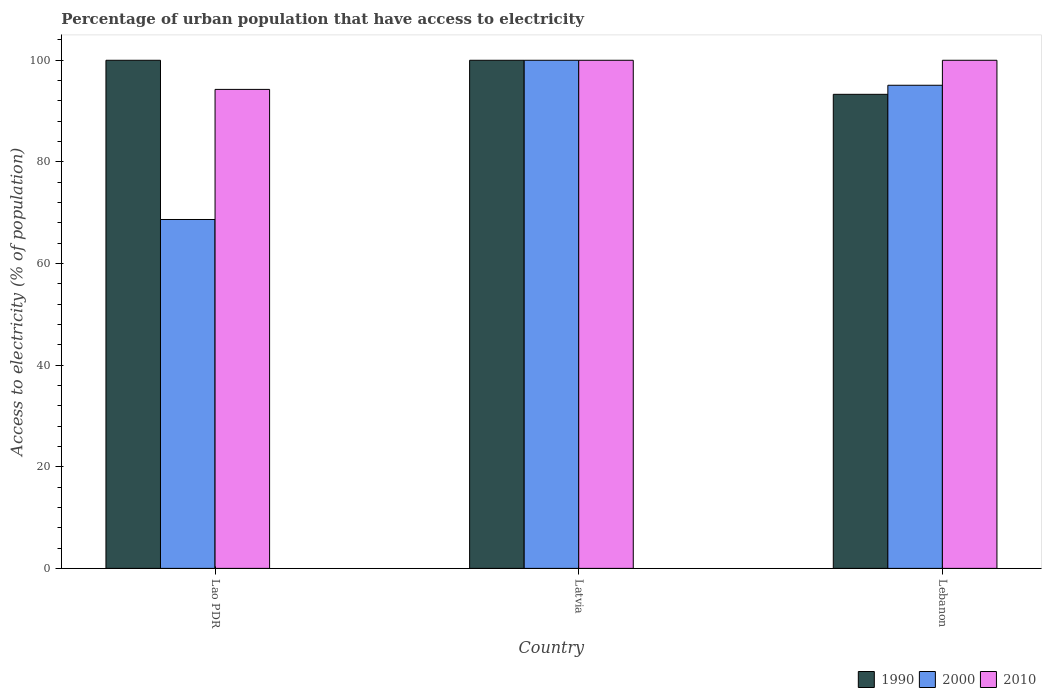How many different coloured bars are there?
Provide a short and direct response. 3. Are the number of bars per tick equal to the number of legend labels?
Offer a terse response. Yes. How many bars are there on the 3rd tick from the left?
Provide a short and direct response. 3. How many bars are there on the 1st tick from the right?
Give a very brief answer. 3. What is the label of the 1st group of bars from the left?
Offer a very short reply. Lao PDR. In how many cases, is the number of bars for a given country not equal to the number of legend labels?
Your answer should be very brief. 0. Across all countries, what is the maximum percentage of urban population that have access to electricity in 2010?
Provide a short and direct response. 100. Across all countries, what is the minimum percentage of urban population that have access to electricity in 2010?
Ensure brevity in your answer.  94.27. In which country was the percentage of urban population that have access to electricity in 1990 maximum?
Keep it short and to the point. Lao PDR. In which country was the percentage of urban population that have access to electricity in 1990 minimum?
Keep it short and to the point. Lebanon. What is the total percentage of urban population that have access to electricity in 1990 in the graph?
Give a very brief answer. 293.3. What is the difference between the percentage of urban population that have access to electricity in 2000 in Lao PDR and that in Lebanon?
Offer a terse response. -26.42. What is the difference between the percentage of urban population that have access to electricity in 1990 in Lebanon and the percentage of urban population that have access to electricity in 2010 in Latvia?
Keep it short and to the point. -6.7. What is the average percentage of urban population that have access to electricity in 2010 per country?
Offer a terse response. 98.09. What is the difference between the percentage of urban population that have access to electricity of/in 2010 and percentage of urban population that have access to electricity of/in 2000 in Lebanon?
Your answer should be very brief. 4.92. What is the ratio of the percentage of urban population that have access to electricity in 2000 in Lao PDR to that in Lebanon?
Offer a terse response. 0.72. Is the percentage of urban population that have access to electricity in 1990 in Lao PDR less than that in Lebanon?
Keep it short and to the point. No. Is the difference between the percentage of urban population that have access to electricity in 2010 in Latvia and Lebanon greater than the difference between the percentage of urban population that have access to electricity in 2000 in Latvia and Lebanon?
Provide a short and direct response. No. What is the difference between the highest and the second highest percentage of urban population that have access to electricity in 2010?
Make the answer very short. 5.73. What is the difference between the highest and the lowest percentage of urban population that have access to electricity in 1990?
Provide a succinct answer. 6.7. In how many countries, is the percentage of urban population that have access to electricity in 2000 greater than the average percentage of urban population that have access to electricity in 2000 taken over all countries?
Provide a succinct answer. 2. What does the 2nd bar from the right in Lebanon represents?
Your answer should be very brief. 2000. Is it the case that in every country, the sum of the percentage of urban population that have access to electricity in 2010 and percentage of urban population that have access to electricity in 2000 is greater than the percentage of urban population that have access to electricity in 1990?
Provide a succinct answer. Yes. Are all the bars in the graph horizontal?
Your response must be concise. No. How many countries are there in the graph?
Keep it short and to the point. 3. What is the difference between two consecutive major ticks on the Y-axis?
Offer a terse response. 20. Does the graph contain any zero values?
Your response must be concise. No. What is the title of the graph?
Provide a short and direct response. Percentage of urban population that have access to electricity. What is the label or title of the Y-axis?
Your answer should be very brief. Access to electricity (% of population). What is the Access to electricity (% of population) of 1990 in Lao PDR?
Your response must be concise. 100. What is the Access to electricity (% of population) in 2000 in Lao PDR?
Your answer should be compact. 68.67. What is the Access to electricity (% of population) in 2010 in Lao PDR?
Your response must be concise. 94.27. What is the Access to electricity (% of population) of 1990 in Latvia?
Provide a succinct answer. 100. What is the Access to electricity (% of population) of 1990 in Lebanon?
Your answer should be very brief. 93.3. What is the Access to electricity (% of population) in 2000 in Lebanon?
Ensure brevity in your answer.  95.08. What is the Access to electricity (% of population) in 2010 in Lebanon?
Ensure brevity in your answer.  100. Across all countries, what is the maximum Access to electricity (% of population) of 1990?
Your response must be concise. 100. Across all countries, what is the maximum Access to electricity (% of population) of 2000?
Your answer should be compact. 100. Across all countries, what is the maximum Access to electricity (% of population) of 2010?
Provide a succinct answer. 100. Across all countries, what is the minimum Access to electricity (% of population) of 1990?
Keep it short and to the point. 93.3. Across all countries, what is the minimum Access to electricity (% of population) of 2000?
Offer a terse response. 68.67. Across all countries, what is the minimum Access to electricity (% of population) of 2010?
Ensure brevity in your answer.  94.27. What is the total Access to electricity (% of population) of 1990 in the graph?
Your response must be concise. 293.3. What is the total Access to electricity (% of population) in 2000 in the graph?
Offer a very short reply. 263.75. What is the total Access to electricity (% of population) in 2010 in the graph?
Your response must be concise. 294.27. What is the difference between the Access to electricity (% of population) in 1990 in Lao PDR and that in Latvia?
Your answer should be very brief. 0. What is the difference between the Access to electricity (% of population) in 2000 in Lao PDR and that in Latvia?
Give a very brief answer. -31.33. What is the difference between the Access to electricity (% of population) of 2010 in Lao PDR and that in Latvia?
Offer a terse response. -5.73. What is the difference between the Access to electricity (% of population) in 1990 in Lao PDR and that in Lebanon?
Offer a terse response. 6.7. What is the difference between the Access to electricity (% of population) in 2000 in Lao PDR and that in Lebanon?
Offer a terse response. -26.42. What is the difference between the Access to electricity (% of population) of 2010 in Lao PDR and that in Lebanon?
Offer a terse response. -5.73. What is the difference between the Access to electricity (% of population) of 1990 in Latvia and that in Lebanon?
Your answer should be compact. 6.7. What is the difference between the Access to electricity (% of population) of 2000 in Latvia and that in Lebanon?
Your response must be concise. 4.92. What is the difference between the Access to electricity (% of population) in 2000 in Lao PDR and the Access to electricity (% of population) in 2010 in Latvia?
Your response must be concise. -31.33. What is the difference between the Access to electricity (% of population) of 1990 in Lao PDR and the Access to electricity (% of population) of 2000 in Lebanon?
Your response must be concise. 4.92. What is the difference between the Access to electricity (% of population) of 1990 in Lao PDR and the Access to electricity (% of population) of 2010 in Lebanon?
Provide a short and direct response. 0. What is the difference between the Access to electricity (% of population) in 2000 in Lao PDR and the Access to electricity (% of population) in 2010 in Lebanon?
Your answer should be very brief. -31.33. What is the difference between the Access to electricity (% of population) in 1990 in Latvia and the Access to electricity (% of population) in 2000 in Lebanon?
Make the answer very short. 4.92. What is the average Access to electricity (% of population) in 1990 per country?
Your answer should be very brief. 97.77. What is the average Access to electricity (% of population) in 2000 per country?
Your answer should be compact. 87.92. What is the average Access to electricity (% of population) in 2010 per country?
Offer a very short reply. 98.09. What is the difference between the Access to electricity (% of population) of 1990 and Access to electricity (% of population) of 2000 in Lao PDR?
Provide a short and direct response. 31.33. What is the difference between the Access to electricity (% of population) in 1990 and Access to electricity (% of population) in 2010 in Lao PDR?
Your answer should be compact. 5.73. What is the difference between the Access to electricity (% of population) in 2000 and Access to electricity (% of population) in 2010 in Lao PDR?
Provide a succinct answer. -25.6. What is the difference between the Access to electricity (% of population) in 1990 and Access to electricity (% of population) in 2000 in Lebanon?
Keep it short and to the point. -1.78. What is the difference between the Access to electricity (% of population) in 1990 and Access to electricity (% of population) in 2010 in Lebanon?
Your answer should be very brief. -6.7. What is the difference between the Access to electricity (% of population) in 2000 and Access to electricity (% of population) in 2010 in Lebanon?
Ensure brevity in your answer.  -4.92. What is the ratio of the Access to electricity (% of population) in 1990 in Lao PDR to that in Latvia?
Ensure brevity in your answer.  1. What is the ratio of the Access to electricity (% of population) of 2000 in Lao PDR to that in Latvia?
Provide a short and direct response. 0.69. What is the ratio of the Access to electricity (% of population) in 2010 in Lao PDR to that in Latvia?
Your response must be concise. 0.94. What is the ratio of the Access to electricity (% of population) of 1990 in Lao PDR to that in Lebanon?
Provide a short and direct response. 1.07. What is the ratio of the Access to electricity (% of population) of 2000 in Lao PDR to that in Lebanon?
Ensure brevity in your answer.  0.72. What is the ratio of the Access to electricity (% of population) of 2010 in Lao PDR to that in Lebanon?
Your answer should be compact. 0.94. What is the ratio of the Access to electricity (% of population) in 1990 in Latvia to that in Lebanon?
Offer a terse response. 1.07. What is the ratio of the Access to electricity (% of population) of 2000 in Latvia to that in Lebanon?
Your response must be concise. 1.05. What is the difference between the highest and the second highest Access to electricity (% of population) in 1990?
Provide a succinct answer. 0. What is the difference between the highest and the second highest Access to electricity (% of population) of 2000?
Provide a succinct answer. 4.92. What is the difference between the highest and the second highest Access to electricity (% of population) of 2010?
Offer a very short reply. 0. What is the difference between the highest and the lowest Access to electricity (% of population) of 1990?
Ensure brevity in your answer.  6.7. What is the difference between the highest and the lowest Access to electricity (% of population) of 2000?
Keep it short and to the point. 31.33. What is the difference between the highest and the lowest Access to electricity (% of population) of 2010?
Provide a short and direct response. 5.73. 